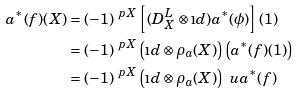Convert formula to latex. <formula><loc_0><loc_0><loc_500><loc_500>a ^ { \ast } ( f ) ( X ) & = ( - 1 ) ^ { \ p { X } } \left [ ( D ^ { L } _ { X } \otimes \i d ) a ^ { \ast } ( \phi ) \right ] ( 1 ) \\ & = ( - 1 ) ^ { \ p { X } } \left ( \i d \otimes \rho _ { a } ( X ) \right ) \left ( a ^ { \ast } ( f ) ( 1 ) \right ) \\ & = ( - 1 ) ^ { \ p { X } } \left ( \i d \otimes \rho _ { a } ( X ) \right ) \ u a ^ { \ast } ( f )</formula> 